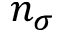<formula> <loc_0><loc_0><loc_500><loc_500>n _ { \sigma }</formula> 